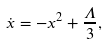Convert formula to latex. <formula><loc_0><loc_0><loc_500><loc_500>\dot { x } = - x ^ { 2 } + \frac { \Lambda } { 3 } ,</formula> 